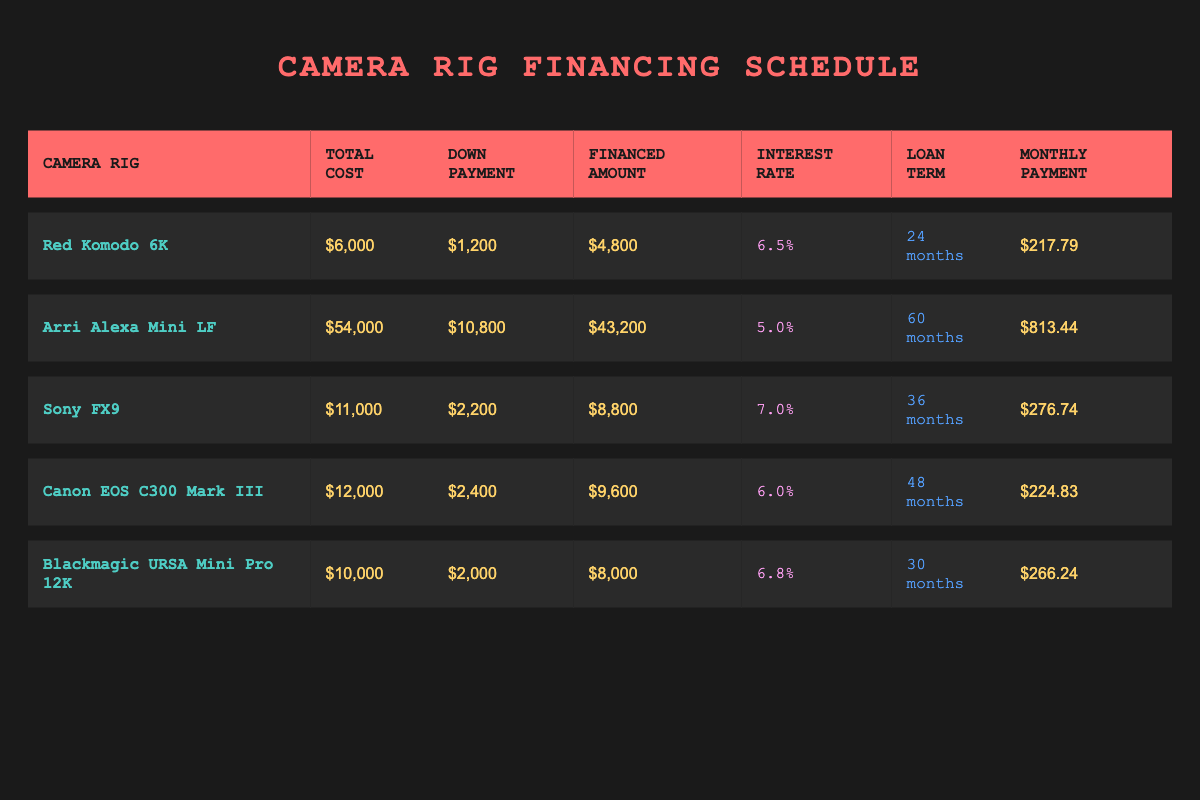What is the total cost of the Canon EOS C300 Mark III? The total cost for the Canon EOS C300 Mark III is listed directly in the table under the "Total Cost" column. It shows $12,000.
Answer: $12,000 What is the financed amount for the Arri Alexa Mini LF? The financed amount for the Arri Alexa Mini LF is displayed in the "Financed Amount" column. It indicates $43,200.
Answer: $43,200 Which camera rig has the highest monthly payment? To find which camera rig has the highest monthly payment, we need to compare the values in the "Monthly Payment" column. The Arri Alexa Mini LF has a payment of $813.44, which is higher than all others.
Answer: Arri Alexa Mini LF Is the interest rate for the Sony FX9 higher than 6%? The interest rate for the Sony FX9 is 7.0% as shown in the "Interest Rate" column. Since 7.0% is greater than 6%, the answer is yes.
Answer: Yes What is the difference in total cost between the Blackmagic URSA Mini Pro 12K and the Red Komodo 6K? The total cost for Blackmagic URSA Mini Pro 12K is $10,000 and for Red Komodo 6K is $6,000. The difference is calculated as $10,000 - $6,000 = $4,000.
Answer: $4,000 How many months in total does the financing for all camera rigs last? The loan terms for the camera rigs are 24, 60, 36, 48, and 30 months respectively. We sum these values: 24 + 60 + 36 + 48 + 30 = 198 months total.
Answer: 198 months Which camera rig has the lowest down payment, and what is that amount? The down payment amounts listed are $1,200 for Red Komodo 6K, $10,800 for Arri Alexa Mini LF, $2,200 for Sony FX9, $2,400 for Canon EOS C300 Mark III, and $2,000 for Blackmagic URSA Mini Pro 12K. The lowest amount is $1,200 for the Red Komodo 6K.
Answer: Red Komodo 6K, $1,200 What is the average monthly payment across all camera rigs? The monthly payments are $217.79, $813.44, $276.74, $224.83, and $266.24. Summing these gives $1,798.04. Dividing by 5 camera rigs (1,798.04 / 5) gives an average monthly payment of $359.61.
Answer: $359.61 Does the Canon EOS C300 Mark III have a lower financed amount than the Sony FX9? The financed amount for Canon EOS C300 Mark III is $9,600, while for Sony FX9 it is $8,800. Since $9,600 is greater than $8,800, the answer is no.
Answer: No 